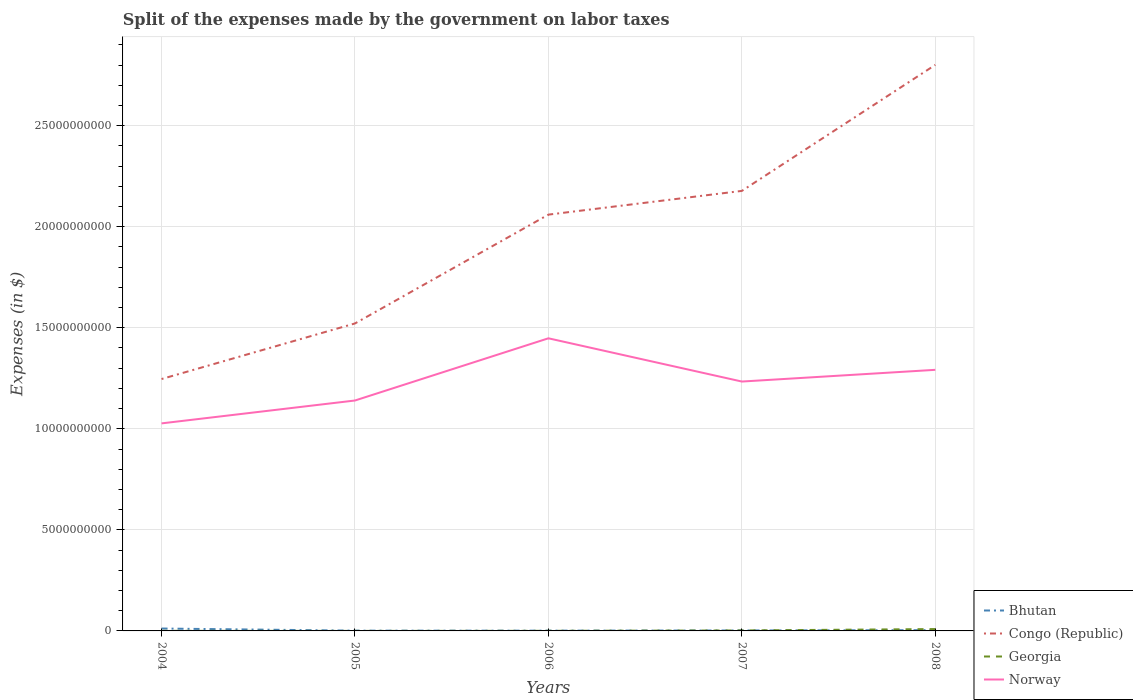How many different coloured lines are there?
Your answer should be compact. 4. Does the line corresponding to Georgia intersect with the line corresponding to Norway?
Provide a succinct answer. No. Across all years, what is the maximum expenses made by the government on labor taxes in Norway?
Offer a terse response. 1.03e+1. In which year was the expenses made by the government on labor taxes in Georgia maximum?
Provide a succinct answer. 2005. What is the total expenses made by the government on labor taxes in Norway in the graph?
Offer a very short reply. -3.08e+09. What is the difference between the highest and the second highest expenses made by the government on labor taxes in Georgia?
Your answer should be very brief. 9.12e+07. What is the difference between the highest and the lowest expenses made by the government on labor taxes in Georgia?
Give a very brief answer. 1. How many years are there in the graph?
Your answer should be very brief. 5. What is the difference between two consecutive major ticks on the Y-axis?
Offer a very short reply. 5.00e+09. Are the values on the major ticks of Y-axis written in scientific E-notation?
Offer a terse response. No. Where does the legend appear in the graph?
Your response must be concise. Bottom right. How many legend labels are there?
Ensure brevity in your answer.  4. What is the title of the graph?
Your response must be concise. Split of the expenses made by the government on labor taxes. What is the label or title of the X-axis?
Provide a succinct answer. Years. What is the label or title of the Y-axis?
Make the answer very short. Expenses (in $). What is the Expenses (in $) in Bhutan in 2004?
Provide a succinct answer. 1.18e+08. What is the Expenses (in $) of Congo (Republic) in 2004?
Ensure brevity in your answer.  1.25e+1. What is the Expenses (in $) in Georgia in 2004?
Keep it short and to the point. 4.00e+06. What is the Expenses (in $) in Norway in 2004?
Your response must be concise. 1.03e+1. What is the Expenses (in $) of Bhutan in 2005?
Offer a terse response. 1.28e+07. What is the Expenses (in $) of Congo (Republic) in 2005?
Make the answer very short. 1.52e+1. What is the Expenses (in $) of Norway in 2005?
Give a very brief answer. 1.14e+1. What is the Expenses (in $) of Bhutan in 2006?
Make the answer very short. 1.35e+07. What is the Expenses (in $) in Congo (Republic) in 2006?
Your answer should be compact. 2.06e+1. What is the Expenses (in $) in Georgia in 2006?
Ensure brevity in your answer.  4.70e+06. What is the Expenses (in $) of Norway in 2006?
Your response must be concise. 1.45e+1. What is the Expenses (in $) in Bhutan in 2007?
Offer a terse response. 2.20e+07. What is the Expenses (in $) in Congo (Republic) in 2007?
Offer a very short reply. 2.18e+1. What is the Expenses (in $) in Georgia in 2007?
Keep it short and to the point. 2.31e+07. What is the Expenses (in $) of Norway in 2007?
Your answer should be compact. 1.23e+1. What is the Expenses (in $) in Bhutan in 2008?
Offer a terse response. 3.87e+07. What is the Expenses (in $) of Congo (Republic) in 2008?
Keep it short and to the point. 2.80e+1. What is the Expenses (in $) of Georgia in 2008?
Offer a terse response. 9.18e+07. What is the Expenses (in $) in Norway in 2008?
Provide a succinct answer. 1.29e+1. Across all years, what is the maximum Expenses (in $) of Bhutan?
Give a very brief answer. 1.18e+08. Across all years, what is the maximum Expenses (in $) of Congo (Republic)?
Offer a terse response. 2.80e+1. Across all years, what is the maximum Expenses (in $) in Georgia?
Offer a very short reply. 9.18e+07. Across all years, what is the maximum Expenses (in $) in Norway?
Ensure brevity in your answer.  1.45e+1. Across all years, what is the minimum Expenses (in $) of Bhutan?
Make the answer very short. 1.28e+07. Across all years, what is the minimum Expenses (in $) in Congo (Republic)?
Offer a very short reply. 1.25e+1. Across all years, what is the minimum Expenses (in $) of Georgia?
Keep it short and to the point. 6.00e+05. Across all years, what is the minimum Expenses (in $) in Norway?
Make the answer very short. 1.03e+1. What is the total Expenses (in $) of Bhutan in the graph?
Offer a very short reply. 2.05e+08. What is the total Expenses (in $) of Congo (Republic) in the graph?
Ensure brevity in your answer.  9.81e+1. What is the total Expenses (in $) of Georgia in the graph?
Your answer should be very brief. 1.24e+08. What is the total Expenses (in $) of Norway in the graph?
Your answer should be compact. 6.14e+1. What is the difference between the Expenses (in $) of Bhutan in 2004 and that in 2005?
Your response must be concise. 1.05e+08. What is the difference between the Expenses (in $) in Congo (Republic) in 2004 and that in 2005?
Your answer should be compact. -2.75e+09. What is the difference between the Expenses (in $) in Georgia in 2004 and that in 2005?
Provide a succinct answer. 3.40e+06. What is the difference between the Expenses (in $) of Norway in 2004 and that in 2005?
Give a very brief answer. -1.13e+09. What is the difference between the Expenses (in $) of Bhutan in 2004 and that in 2006?
Your answer should be compact. 1.05e+08. What is the difference between the Expenses (in $) in Congo (Republic) in 2004 and that in 2006?
Your answer should be very brief. -8.14e+09. What is the difference between the Expenses (in $) of Georgia in 2004 and that in 2006?
Keep it short and to the point. -7.00e+05. What is the difference between the Expenses (in $) of Norway in 2004 and that in 2006?
Provide a short and direct response. -4.21e+09. What is the difference between the Expenses (in $) of Bhutan in 2004 and that in 2007?
Your response must be concise. 9.61e+07. What is the difference between the Expenses (in $) of Congo (Republic) in 2004 and that in 2007?
Make the answer very short. -9.31e+09. What is the difference between the Expenses (in $) of Georgia in 2004 and that in 2007?
Your response must be concise. -1.91e+07. What is the difference between the Expenses (in $) in Norway in 2004 and that in 2007?
Give a very brief answer. -2.07e+09. What is the difference between the Expenses (in $) of Bhutan in 2004 and that in 2008?
Your response must be concise. 7.95e+07. What is the difference between the Expenses (in $) in Congo (Republic) in 2004 and that in 2008?
Give a very brief answer. -1.55e+1. What is the difference between the Expenses (in $) in Georgia in 2004 and that in 2008?
Make the answer very short. -8.78e+07. What is the difference between the Expenses (in $) of Norway in 2004 and that in 2008?
Keep it short and to the point. -2.65e+09. What is the difference between the Expenses (in $) in Bhutan in 2005 and that in 2006?
Your answer should be very brief. -6.82e+05. What is the difference between the Expenses (in $) of Congo (Republic) in 2005 and that in 2006?
Make the answer very short. -5.38e+09. What is the difference between the Expenses (in $) of Georgia in 2005 and that in 2006?
Give a very brief answer. -4.10e+06. What is the difference between the Expenses (in $) in Norway in 2005 and that in 2006?
Make the answer very short. -3.08e+09. What is the difference between the Expenses (in $) of Bhutan in 2005 and that in 2007?
Provide a succinct answer. -9.28e+06. What is the difference between the Expenses (in $) in Congo (Republic) in 2005 and that in 2007?
Your answer should be very brief. -6.56e+09. What is the difference between the Expenses (in $) of Georgia in 2005 and that in 2007?
Your answer should be compact. -2.25e+07. What is the difference between the Expenses (in $) of Norway in 2005 and that in 2007?
Offer a terse response. -9.38e+08. What is the difference between the Expenses (in $) of Bhutan in 2005 and that in 2008?
Provide a succinct answer. -2.59e+07. What is the difference between the Expenses (in $) of Congo (Republic) in 2005 and that in 2008?
Offer a very short reply. -1.28e+1. What is the difference between the Expenses (in $) of Georgia in 2005 and that in 2008?
Offer a terse response. -9.12e+07. What is the difference between the Expenses (in $) of Norway in 2005 and that in 2008?
Provide a succinct answer. -1.52e+09. What is the difference between the Expenses (in $) in Bhutan in 2006 and that in 2007?
Your answer should be compact. -8.59e+06. What is the difference between the Expenses (in $) of Congo (Republic) in 2006 and that in 2007?
Your answer should be very brief. -1.17e+09. What is the difference between the Expenses (in $) of Georgia in 2006 and that in 2007?
Provide a short and direct response. -1.84e+07. What is the difference between the Expenses (in $) of Norway in 2006 and that in 2007?
Provide a succinct answer. 2.14e+09. What is the difference between the Expenses (in $) in Bhutan in 2006 and that in 2008?
Give a very brief answer. -2.52e+07. What is the difference between the Expenses (in $) of Congo (Republic) in 2006 and that in 2008?
Offer a very short reply. -7.41e+09. What is the difference between the Expenses (in $) in Georgia in 2006 and that in 2008?
Provide a succinct answer. -8.71e+07. What is the difference between the Expenses (in $) in Norway in 2006 and that in 2008?
Make the answer very short. 1.56e+09. What is the difference between the Expenses (in $) in Bhutan in 2007 and that in 2008?
Offer a terse response. -1.66e+07. What is the difference between the Expenses (in $) in Congo (Republic) in 2007 and that in 2008?
Offer a very short reply. -6.24e+09. What is the difference between the Expenses (in $) of Georgia in 2007 and that in 2008?
Provide a short and direct response. -6.87e+07. What is the difference between the Expenses (in $) of Norway in 2007 and that in 2008?
Offer a very short reply. -5.80e+08. What is the difference between the Expenses (in $) of Bhutan in 2004 and the Expenses (in $) of Congo (Republic) in 2005?
Make the answer very short. -1.51e+1. What is the difference between the Expenses (in $) in Bhutan in 2004 and the Expenses (in $) in Georgia in 2005?
Offer a terse response. 1.18e+08. What is the difference between the Expenses (in $) of Bhutan in 2004 and the Expenses (in $) of Norway in 2005?
Your answer should be very brief. -1.13e+1. What is the difference between the Expenses (in $) of Congo (Republic) in 2004 and the Expenses (in $) of Georgia in 2005?
Your answer should be very brief. 1.25e+1. What is the difference between the Expenses (in $) in Congo (Republic) in 2004 and the Expenses (in $) in Norway in 2005?
Give a very brief answer. 1.06e+09. What is the difference between the Expenses (in $) in Georgia in 2004 and the Expenses (in $) in Norway in 2005?
Offer a terse response. -1.14e+1. What is the difference between the Expenses (in $) of Bhutan in 2004 and the Expenses (in $) of Congo (Republic) in 2006?
Keep it short and to the point. -2.05e+1. What is the difference between the Expenses (in $) in Bhutan in 2004 and the Expenses (in $) in Georgia in 2006?
Offer a terse response. 1.13e+08. What is the difference between the Expenses (in $) of Bhutan in 2004 and the Expenses (in $) of Norway in 2006?
Give a very brief answer. -1.44e+1. What is the difference between the Expenses (in $) of Congo (Republic) in 2004 and the Expenses (in $) of Georgia in 2006?
Make the answer very short. 1.25e+1. What is the difference between the Expenses (in $) in Congo (Republic) in 2004 and the Expenses (in $) in Norway in 2006?
Give a very brief answer. -2.02e+09. What is the difference between the Expenses (in $) of Georgia in 2004 and the Expenses (in $) of Norway in 2006?
Offer a terse response. -1.45e+1. What is the difference between the Expenses (in $) of Bhutan in 2004 and the Expenses (in $) of Congo (Republic) in 2007?
Your response must be concise. -2.17e+1. What is the difference between the Expenses (in $) in Bhutan in 2004 and the Expenses (in $) in Georgia in 2007?
Keep it short and to the point. 9.51e+07. What is the difference between the Expenses (in $) of Bhutan in 2004 and the Expenses (in $) of Norway in 2007?
Your answer should be compact. -1.22e+1. What is the difference between the Expenses (in $) in Congo (Republic) in 2004 and the Expenses (in $) in Georgia in 2007?
Your response must be concise. 1.24e+1. What is the difference between the Expenses (in $) in Congo (Republic) in 2004 and the Expenses (in $) in Norway in 2007?
Keep it short and to the point. 1.25e+08. What is the difference between the Expenses (in $) in Georgia in 2004 and the Expenses (in $) in Norway in 2007?
Provide a short and direct response. -1.23e+1. What is the difference between the Expenses (in $) in Bhutan in 2004 and the Expenses (in $) in Congo (Republic) in 2008?
Keep it short and to the point. -2.79e+1. What is the difference between the Expenses (in $) in Bhutan in 2004 and the Expenses (in $) in Georgia in 2008?
Offer a terse response. 2.64e+07. What is the difference between the Expenses (in $) in Bhutan in 2004 and the Expenses (in $) in Norway in 2008?
Your response must be concise. -1.28e+1. What is the difference between the Expenses (in $) in Congo (Republic) in 2004 and the Expenses (in $) in Georgia in 2008?
Your response must be concise. 1.24e+1. What is the difference between the Expenses (in $) of Congo (Republic) in 2004 and the Expenses (in $) of Norway in 2008?
Provide a short and direct response. -4.55e+08. What is the difference between the Expenses (in $) in Georgia in 2004 and the Expenses (in $) in Norway in 2008?
Ensure brevity in your answer.  -1.29e+1. What is the difference between the Expenses (in $) in Bhutan in 2005 and the Expenses (in $) in Congo (Republic) in 2006?
Offer a terse response. -2.06e+1. What is the difference between the Expenses (in $) of Bhutan in 2005 and the Expenses (in $) of Georgia in 2006?
Ensure brevity in your answer.  8.08e+06. What is the difference between the Expenses (in $) of Bhutan in 2005 and the Expenses (in $) of Norway in 2006?
Offer a terse response. -1.45e+1. What is the difference between the Expenses (in $) of Congo (Republic) in 2005 and the Expenses (in $) of Georgia in 2006?
Ensure brevity in your answer.  1.52e+1. What is the difference between the Expenses (in $) of Congo (Republic) in 2005 and the Expenses (in $) of Norway in 2006?
Offer a terse response. 7.35e+08. What is the difference between the Expenses (in $) in Georgia in 2005 and the Expenses (in $) in Norway in 2006?
Offer a terse response. -1.45e+1. What is the difference between the Expenses (in $) of Bhutan in 2005 and the Expenses (in $) of Congo (Republic) in 2007?
Your answer should be compact. -2.18e+1. What is the difference between the Expenses (in $) in Bhutan in 2005 and the Expenses (in $) in Georgia in 2007?
Ensure brevity in your answer.  -1.03e+07. What is the difference between the Expenses (in $) in Bhutan in 2005 and the Expenses (in $) in Norway in 2007?
Give a very brief answer. -1.23e+1. What is the difference between the Expenses (in $) in Congo (Republic) in 2005 and the Expenses (in $) in Georgia in 2007?
Your answer should be compact. 1.52e+1. What is the difference between the Expenses (in $) in Congo (Republic) in 2005 and the Expenses (in $) in Norway in 2007?
Offer a very short reply. 2.88e+09. What is the difference between the Expenses (in $) in Georgia in 2005 and the Expenses (in $) in Norway in 2007?
Provide a short and direct response. -1.23e+1. What is the difference between the Expenses (in $) in Bhutan in 2005 and the Expenses (in $) in Congo (Republic) in 2008?
Your response must be concise. -2.80e+1. What is the difference between the Expenses (in $) of Bhutan in 2005 and the Expenses (in $) of Georgia in 2008?
Ensure brevity in your answer.  -7.90e+07. What is the difference between the Expenses (in $) of Bhutan in 2005 and the Expenses (in $) of Norway in 2008?
Give a very brief answer. -1.29e+1. What is the difference between the Expenses (in $) of Congo (Republic) in 2005 and the Expenses (in $) of Georgia in 2008?
Keep it short and to the point. 1.51e+1. What is the difference between the Expenses (in $) of Congo (Republic) in 2005 and the Expenses (in $) of Norway in 2008?
Offer a terse response. 2.30e+09. What is the difference between the Expenses (in $) in Georgia in 2005 and the Expenses (in $) in Norway in 2008?
Your response must be concise. -1.29e+1. What is the difference between the Expenses (in $) in Bhutan in 2006 and the Expenses (in $) in Congo (Republic) in 2007?
Offer a terse response. -2.18e+1. What is the difference between the Expenses (in $) in Bhutan in 2006 and the Expenses (in $) in Georgia in 2007?
Provide a short and direct response. -9.64e+06. What is the difference between the Expenses (in $) of Bhutan in 2006 and the Expenses (in $) of Norway in 2007?
Make the answer very short. -1.23e+1. What is the difference between the Expenses (in $) of Congo (Republic) in 2006 and the Expenses (in $) of Georgia in 2007?
Offer a terse response. 2.06e+1. What is the difference between the Expenses (in $) in Congo (Republic) in 2006 and the Expenses (in $) in Norway in 2007?
Provide a short and direct response. 8.26e+09. What is the difference between the Expenses (in $) of Georgia in 2006 and the Expenses (in $) of Norway in 2007?
Your response must be concise. -1.23e+1. What is the difference between the Expenses (in $) in Bhutan in 2006 and the Expenses (in $) in Congo (Republic) in 2008?
Your answer should be compact. -2.80e+1. What is the difference between the Expenses (in $) in Bhutan in 2006 and the Expenses (in $) in Georgia in 2008?
Make the answer very short. -7.83e+07. What is the difference between the Expenses (in $) in Bhutan in 2006 and the Expenses (in $) in Norway in 2008?
Make the answer very short. -1.29e+1. What is the difference between the Expenses (in $) of Congo (Republic) in 2006 and the Expenses (in $) of Georgia in 2008?
Offer a terse response. 2.05e+1. What is the difference between the Expenses (in $) of Congo (Republic) in 2006 and the Expenses (in $) of Norway in 2008?
Offer a very short reply. 7.68e+09. What is the difference between the Expenses (in $) of Georgia in 2006 and the Expenses (in $) of Norway in 2008?
Offer a terse response. -1.29e+1. What is the difference between the Expenses (in $) of Bhutan in 2007 and the Expenses (in $) of Congo (Republic) in 2008?
Give a very brief answer. -2.80e+1. What is the difference between the Expenses (in $) of Bhutan in 2007 and the Expenses (in $) of Georgia in 2008?
Your response must be concise. -6.98e+07. What is the difference between the Expenses (in $) of Bhutan in 2007 and the Expenses (in $) of Norway in 2008?
Offer a very short reply. -1.29e+1. What is the difference between the Expenses (in $) of Congo (Republic) in 2007 and the Expenses (in $) of Georgia in 2008?
Offer a very short reply. 2.17e+1. What is the difference between the Expenses (in $) of Congo (Republic) in 2007 and the Expenses (in $) of Norway in 2008?
Make the answer very short. 8.85e+09. What is the difference between the Expenses (in $) in Georgia in 2007 and the Expenses (in $) in Norway in 2008?
Give a very brief answer. -1.29e+1. What is the average Expenses (in $) of Bhutan per year?
Provide a short and direct response. 4.10e+07. What is the average Expenses (in $) of Congo (Republic) per year?
Give a very brief answer. 1.96e+1. What is the average Expenses (in $) of Georgia per year?
Ensure brevity in your answer.  2.48e+07. What is the average Expenses (in $) in Norway per year?
Give a very brief answer. 1.23e+1. In the year 2004, what is the difference between the Expenses (in $) in Bhutan and Expenses (in $) in Congo (Republic)?
Your answer should be very brief. -1.23e+1. In the year 2004, what is the difference between the Expenses (in $) of Bhutan and Expenses (in $) of Georgia?
Provide a short and direct response. 1.14e+08. In the year 2004, what is the difference between the Expenses (in $) in Bhutan and Expenses (in $) in Norway?
Provide a short and direct response. -1.02e+1. In the year 2004, what is the difference between the Expenses (in $) of Congo (Republic) and Expenses (in $) of Georgia?
Your answer should be very brief. 1.25e+1. In the year 2004, what is the difference between the Expenses (in $) in Congo (Republic) and Expenses (in $) in Norway?
Your answer should be very brief. 2.19e+09. In the year 2004, what is the difference between the Expenses (in $) in Georgia and Expenses (in $) in Norway?
Your answer should be compact. -1.03e+1. In the year 2005, what is the difference between the Expenses (in $) of Bhutan and Expenses (in $) of Congo (Republic)?
Keep it short and to the point. -1.52e+1. In the year 2005, what is the difference between the Expenses (in $) in Bhutan and Expenses (in $) in Georgia?
Keep it short and to the point. 1.22e+07. In the year 2005, what is the difference between the Expenses (in $) of Bhutan and Expenses (in $) of Norway?
Your answer should be very brief. -1.14e+1. In the year 2005, what is the difference between the Expenses (in $) in Congo (Republic) and Expenses (in $) in Georgia?
Keep it short and to the point. 1.52e+1. In the year 2005, what is the difference between the Expenses (in $) in Congo (Republic) and Expenses (in $) in Norway?
Give a very brief answer. 3.81e+09. In the year 2005, what is the difference between the Expenses (in $) of Georgia and Expenses (in $) of Norway?
Provide a succinct answer. -1.14e+1. In the year 2006, what is the difference between the Expenses (in $) of Bhutan and Expenses (in $) of Congo (Republic)?
Offer a terse response. -2.06e+1. In the year 2006, what is the difference between the Expenses (in $) of Bhutan and Expenses (in $) of Georgia?
Your response must be concise. 8.76e+06. In the year 2006, what is the difference between the Expenses (in $) of Bhutan and Expenses (in $) of Norway?
Provide a succinct answer. -1.45e+1. In the year 2006, what is the difference between the Expenses (in $) of Congo (Republic) and Expenses (in $) of Georgia?
Your answer should be compact. 2.06e+1. In the year 2006, what is the difference between the Expenses (in $) in Congo (Republic) and Expenses (in $) in Norway?
Your response must be concise. 6.12e+09. In the year 2006, what is the difference between the Expenses (in $) in Georgia and Expenses (in $) in Norway?
Your answer should be very brief. -1.45e+1. In the year 2007, what is the difference between the Expenses (in $) of Bhutan and Expenses (in $) of Congo (Republic)?
Your answer should be very brief. -2.18e+1. In the year 2007, what is the difference between the Expenses (in $) in Bhutan and Expenses (in $) in Georgia?
Ensure brevity in your answer.  -1.05e+06. In the year 2007, what is the difference between the Expenses (in $) of Bhutan and Expenses (in $) of Norway?
Your response must be concise. -1.23e+1. In the year 2007, what is the difference between the Expenses (in $) of Congo (Republic) and Expenses (in $) of Georgia?
Make the answer very short. 2.18e+1. In the year 2007, what is the difference between the Expenses (in $) of Congo (Republic) and Expenses (in $) of Norway?
Your answer should be compact. 9.43e+09. In the year 2007, what is the difference between the Expenses (in $) in Georgia and Expenses (in $) in Norway?
Make the answer very short. -1.23e+1. In the year 2008, what is the difference between the Expenses (in $) of Bhutan and Expenses (in $) of Congo (Republic)?
Ensure brevity in your answer.  -2.80e+1. In the year 2008, what is the difference between the Expenses (in $) in Bhutan and Expenses (in $) in Georgia?
Your answer should be compact. -5.31e+07. In the year 2008, what is the difference between the Expenses (in $) in Bhutan and Expenses (in $) in Norway?
Your response must be concise. -1.29e+1. In the year 2008, what is the difference between the Expenses (in $) in Congo (Republic) and Expenses (in $) in Georgia?
Your answer should be compact. 2.79e+1. In the year 2008, what is the difference between the Expenses (in $) in Congo (Republic) and Expenses (in $) in Norway?
Offer a terse response. 1.51e+1. In the year 2008, what is the difference between the Expenses (in $) of Georgia and Expenses (in $) of Norway?
Offer a very short reply. -1.28e+1. What is the ratio of the Expenses (in $) in Bhutan in 2004 to that in 2005?
Your response must be concise. 9.25. What is the ratio of the Expenses (in $) in Congo (Republic) in 2004 to that in 2005?
Keep it short and to the point. 0.82. What is the ratio of the Expenses (in $) of Georgia in 2004 to that in 2005?
Keep it short and to the point. 6.67. What is the ratio of the Expenses (in $) in Norway in 2004 to that in 2005?
Ensure brevity in your answer.  0.9. What is the ratio of the Expenses (in $) in Bhutan in 2004 to that in 2006?
Keep it short and to the point. 8.78. What is the ratio of the Expenses (in $) in Congo (Republic) in 2004 to that in 2006?
Keep it short and to the point. 0.61. What is the ratio of the Expenses (in $) in Georgia in 2004 to that in 2006?
Your response must be concise. 0.85. What is the ratio of the Expenses (in $) in Norway in 2004 to that in 2006?
Offer a very short reply. 0.71. What is the ratio of the Expenses (in $) of Bhutan in 2004 to that in 2007?
Your answer should be compact. 5.36. What is the ratio of the Expenses (in $) of Congo (Republic) in 2004 to that in 2007?
Keep it short and to the point. 0.57. What is the ratio of the Expenses (in $) of Georgia in 2004 to that in 2007?
Your answer should be compact. 0.17. What is the ratio of the Expenses (in $) in Norway in 2004 to that in 2007?
Offer a terse response. 0.83. What is the ratio of the Expenses (in $) in Bhutan in 2004 to that in 2008?
Ensure brevity in your answer.  3.06. What is the ratio of the Expenses (in $) in Congo (Republic) in 2004 to that in 2008?
Your answer should be very brief. 0.45. What is the ratio of the Expenses (in $) of Georgia in 2004 to that in 2008?
Offer a very short reply. 0.04. What is the ratio of the Expenses (in $) in Norway in 2004 to that in 2008?
Ensure brevity in your answer.  0.79. What is the ratio of the Expenses (in $) of Bhutan in 2005 to that in 2006?
Ensure brevity in your answer.  0.95. What is the ratio of the Expenses (in $) of Congo (Republic) in 2005 to that in 2006?
Offer a very short reply. 0.74. What is the ratio of the Expenses (in $) in Georgia in 2005 to that in 2006?
Provide a short and direct response. 0.13. What is the ratio of the Expenses (in $) in Norway in 2005 to that in 2006?
Your response must be concise. 0.79. What is the ratio of the Expenses (in $) in Bhutan in 2005 to that in 2007?
Your answer should be compact. 0.58. What is the ratio of the Expenses (in $) of Congo (Republic) in 2005 to that in 2007?
Make the answer very short. 0.7. What is the ratio of the Expenses (in $) of Georgia in 2005 to that in 2007?
Ensure brevity in your answer.  0.03. What is the ratio of the Expenses (in $) of Norway in 2005 to that in 2007?
Offer a terse response. 0.92. What is the ratio of the Expenses (in $) in Bhutan in 2005 to that in 2008?
Provide a succinct answer. 0.33. What is the ratio of the Expenses (in $) in Congo (Republic) in 2005 to that in 2008?
Your response must be concise. 0.54. What is the ratio of the Expenses (in $) of Georgia in 2005 to that in 2008?
Keep it short and to the point. 0.01. What is the ratio of the Expenses (in $) of Norway in 2005 to that in 2008?
Give a very brief answer. 0.88. What is the ratio of the Expenses (in $) of Bhutan in 2006 to that in 2007?
Provide a short and direct response. 0.61. What is the ratio of the Expenses (in $) of Congo (Republic) in 2006 to that in 2007?
Your response must be concise. 0.95. What is the ratio of the Expenses (in $) of Georgia in 2006 to that in 2007?
Offer a very short reply. 0.2. What is the ratio of the Expenses (in $) in Norway in 2006 to that in 2007?
Give a very brief answer. 1.17. What is the ratio of the Expenses (in $) in Bhutan in 2006 to that in 2008?
Offer a terse response. 0.35. What is the ratio of the Expenses (in $) of Congo (Republic) in 2006 to that in 2008?
Keep it short and to the point. 0.74. What is the ratio of the Expenses (in $) in Georgia in 2006 to that in 2008?
Provide a short and direct response. 0.05. What is the ratio of the Expenses (in $) in Norway in 2006 to that in 2008?
Keep it short and to the point. 1.12. What is the ratio of the Expenses (in $) in Bhutan in 2007 to that in 2008?
Your response must be concise. 0.57. What is the ratio of the Expenses (in $) of Congo (Republic) in 2007 to that in 2008?
Your response must be concise. 0.78. What is the ratio of the Expenses (in $) of Georgia in 2007 to that in 2008?
Keep it short and to the point. 0.25. What is the ratio of the Expenses (in $) of Norway in 2007 to that in 2008?
Keep it short and to the point. 0.96. What is the difference between the highest and the second highest Expenses (in $) in Bhutan?
Provide a short and direct response. 7.95e+07. What is the difference between the highest and the second highest Expenses (in $) in Congo (Republic)?
Your response must be concise. 6.24e+09. What is the difference between the highest and the second highest Expenses (in $) in Georgia?
Offer a very short reply. 6.87e+07. What is the difference between the highest and the second highest Expenses (in $) in Norway?
Your response must be concise. 1.56e+09. What is the difference between the highest and the lowest Expenses (in $) in Bhutan?
Your response must be concise. 1.05e+08. What is the difference between the highest and the lowest Expenses (in $) in Congo (Republic)?
Provide a short and direct response. 1.55e+1. What is the difference between the highest and the lowest Expenses (in $) in Georgia?
Provide a short and direct response. 9.12e+07. What is the difference between the highest and the lowest Expenses (in $) in Norway?
Give a very brief answer. 4.21e+09. 